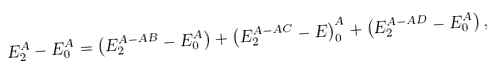<formula> <loc_0><loc_0><loc_500><loc_500>E _ { 2 } ^ { A } - E _ { 0 } ^ { A } = \left ( E _ { 2 } ^ { A - A B } - E _ { 0 } ^ { A } \right ) + \left ( E _ { 2 } ^ { A - A C } - E \right ) _ { 0 } ^ { A } + \left ( E _ { 2 } ^ { A - A D } - E _ { 0 } ^ { A } \right ) ,</formula> 